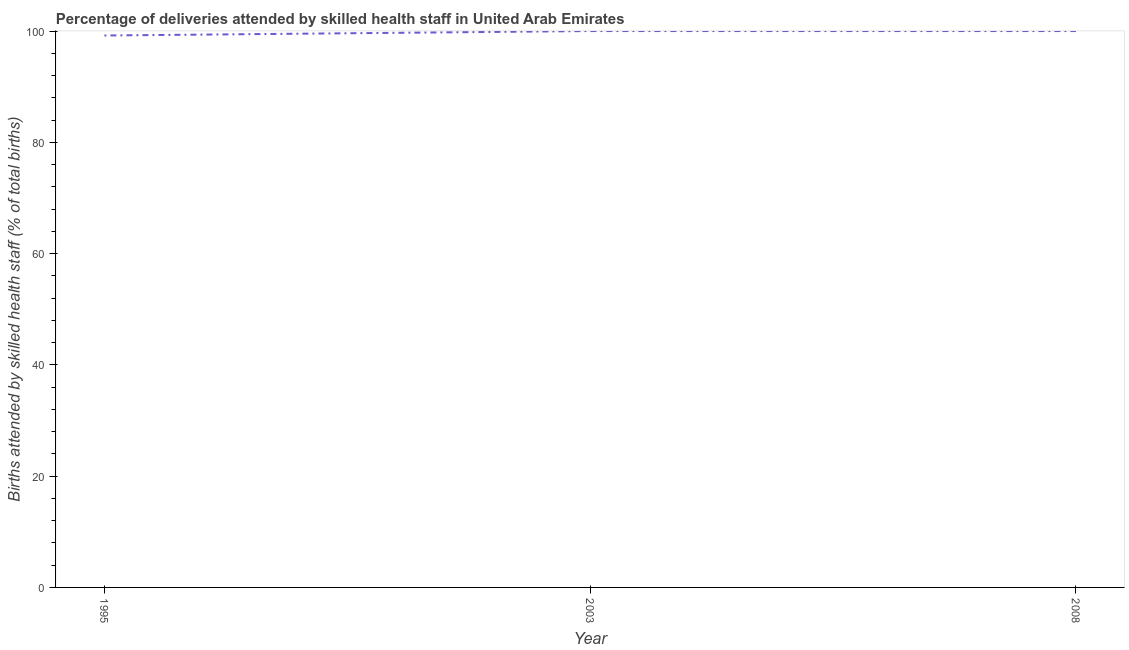What is the number of births attended by skilled health staff in 1995?
Provide a succinct answer. 99.2. Across all years, what is the minimum number of births attended by skilled health staff?
Ensure brevity in your answer.  99.2. In which year was the number of births attended by skilled health staff maximum?
Ensure brevity in your answer.  2003. What is the sum of the number of births attended by skilled health staff?
Provide a short and direct response. 299.2. What is the difference between the number of births attended by skilled health staff in 1995 and 2008?
Keep it short and to the point. -0.8. What is the average number of births attended by skilled health staff per year?
Provide a succinct answer. 99.73. In how many years, is the number of births attended by skilled health staff greater than 68 %?
Your answer should be compact. 3. Do a majority of the years between 1995 and 2008 (inclusive) have number of births attended by skilled health staff greater than 88 %?
Keep it short and to the point. Yes. What is the ratio of the number of births attended by skilled health staff in 1995 to that in 2003?
Offer a terse response. 0.99. Is the number of births attended by skilled health staff in 1995 less than that in 2008?
Give a very brief answer. Yes. Is the difference between the number of births attended by skilled health staff in 2003 and 2008 greater than the difference between any two years?
Make the answer very short. No. Is the sum of the number of births attended by skilled health staff in 1995 and 2008 greater than the maximum number of births attended by skilled health staff across all years?
Ensure brevity in your answer.  Yes. What is the difference between the highest and the lowest number of births attended by skilled health staff?
Your response must be concise. 0.8. Does the number of births attended by skilled health staff monotonically increase over the years?
Your answer should be very brief. No. How many lines are there?
Offer a terse response. 1. Does the graph contain any zero values?
Keep it short and to the point. No. What is the title of the graph?
Give a very brief answer. Percentage of deliveries attended by skilled health staff in United Arab Emirates. What is the label or title of the Y-axis?
Offer a very short reply. Births attended by skilled health staff (% of total births). What is the Births attended by skilled health staff (% of total births) in 1995?
Keep it short and to the point. 99.2. What is the Births attended by skilled health staff (% of total births) of 2003?
Make the answer very short. 100. What is the Births attended by skilled health staff (% of total births) of 2008?
Provide a succinct answer. 100. What is the difference between the Births attended by skilled health staff (% of total births) in 1995 and 2003?
Provide a short and direct response. -0.8. What is the difference between the Births attended by skilled health staff (% of total births) in 1995 and 2008?
Provide a short and direct response. -0.8. What is the difference between the Births attended by skilled health staff (% of total births) in 2003 and 2008?
Ensure brevity in your answer.  0. What is the ratio of the Births attended by skilled health staff (% of total births) in 1995 to that in 2008?
Offer a terse response. 0.99. 